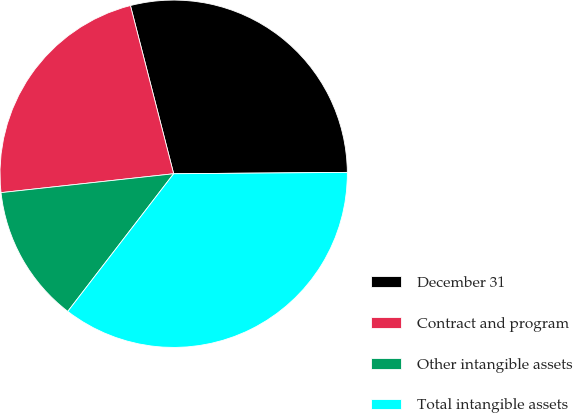Convert chart. <chart><loc_0><loc_0><loc_500><loc_500><pie_chart><fcel>December 31<fcel>Contract and program<fcel>Other intangible assets<fcel>Total intangible assets<nl><fcel>28.88%<fcel>22.73%<fcel>12.83%<fcel>35.56%<nl></chart> 